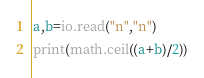<code> <loc_0><loc_0><loc_500><loc_500><_Lua_>a,b=io.read("n","n")
print(math.ceil((a+b)/2))</code> 